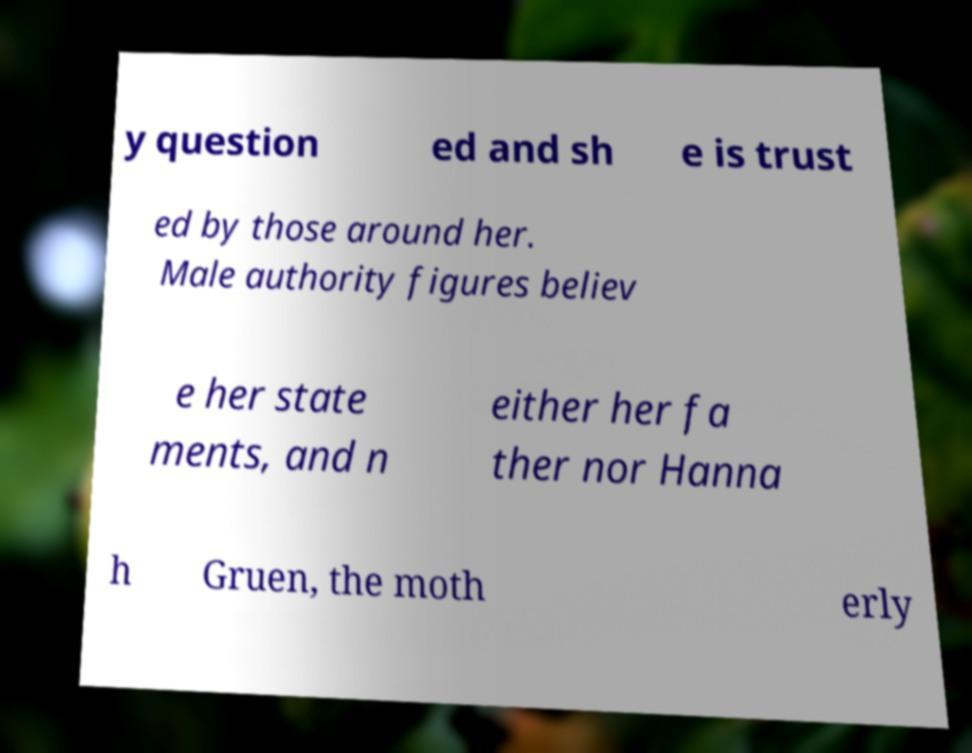Can you read and provide the text displayed in the image?This photo seems to have some interesting text. Can you extract and type it out for me? y question ed and sh e is trust ed by those around her. Male authority figures believ e her state ments, and n either her fa ther nor Hanna h Gruen, the moth erly 